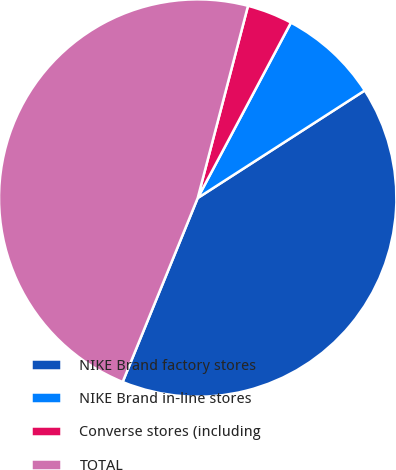Convert chart to OTSL. <chart><loc_0><loc_0><loc_500><loc_500><pie_chart><fcel>NIKE Brand factory stores<fcel>NIKE Brand in-line stores<fcel>Converse stores (including<fcel>TOTAL<nl><fcel>40.27%<fcel>8.12%<fcel>3.7%<fcel>47.91%<nl></chart> 